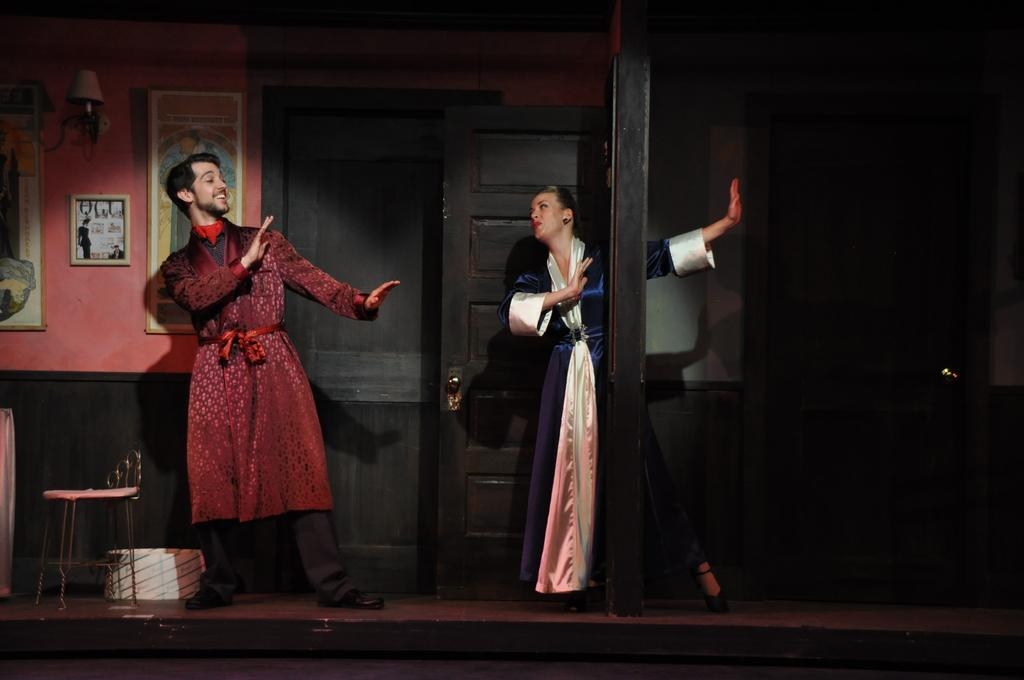How many people are present in the image? There is a man and a woman in the image. What is the man doing in the image? The provided facts do not specify what the man is doing. What is the woman doing in the image? The provided facts do not specify what the woman is doing. What type of furniture is in the image? There is a chair in the image. What is located on the wall in the background of the image? There are frames on the wall in the background of the image. What type of silk is draped over the chair in the image? There is no silk present in the image; it only mentions a chair and a box. How many ears of corn are visible on the table in the image? There is no corn present in the image; it only mentions a chair, a box, and frames on the wall. 